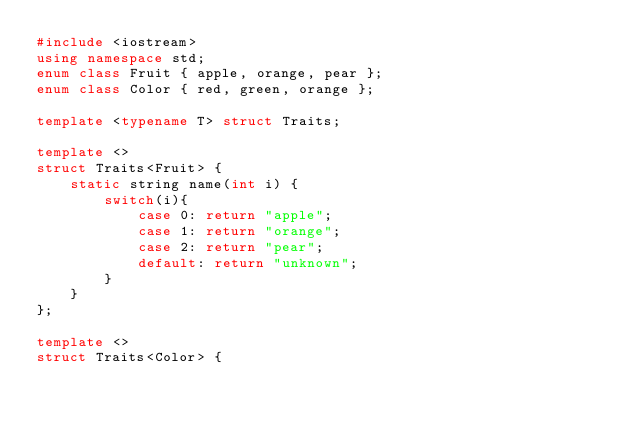Convert code to text. <code><loc_0><loc_0><loc_500><loc_500><_C++_>#include <iostream>
using namespace std;
enum class Fruit { apple, orange, pear };
enum class Color { red, green, orange };

template <typename T> struct Traits;

template <> 
struct Traits<Fruit> {
    static string name(int i) {
        switch(i){
            case 0: return "apple";
            case 1: return "orange";
            case 2: return "pear";
            default: return "unknown";
        }
    }
};

template <> 
struct Traits<Color> {</code> 